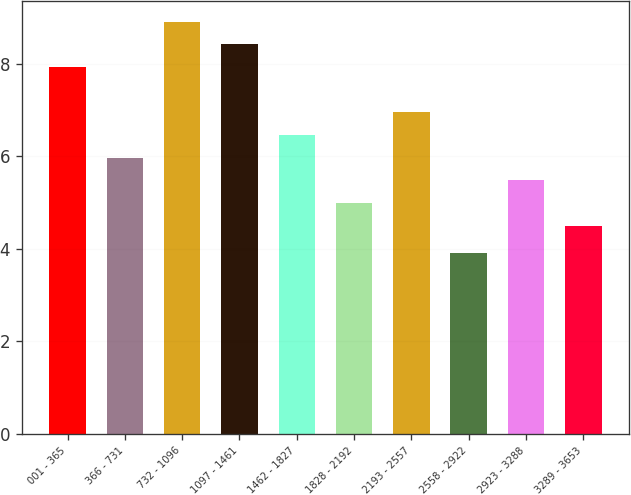Convert chart. <chart><loc_0><loc_0><loc_500><loc_500><bar_chart><fcel>001 - 365<fcel>366 - 731<fcel>732 - 1096<fcel>1097 - 1461<fcel>1462 - 1827<fcel>1828 - 2192<fcel>2193 - 2557<fcel>2558 - 2922<fcel>2923 - 3288<fcel>3289 - 3653<nl><fcel>7.93<fcel>5.97<fcel>8.91<fcel>8.42<fcel>6.46<fcel>4.99<fcel>6.95<fcel>3.9<fcel>5.48<fcel>4.5<nl></chart> 